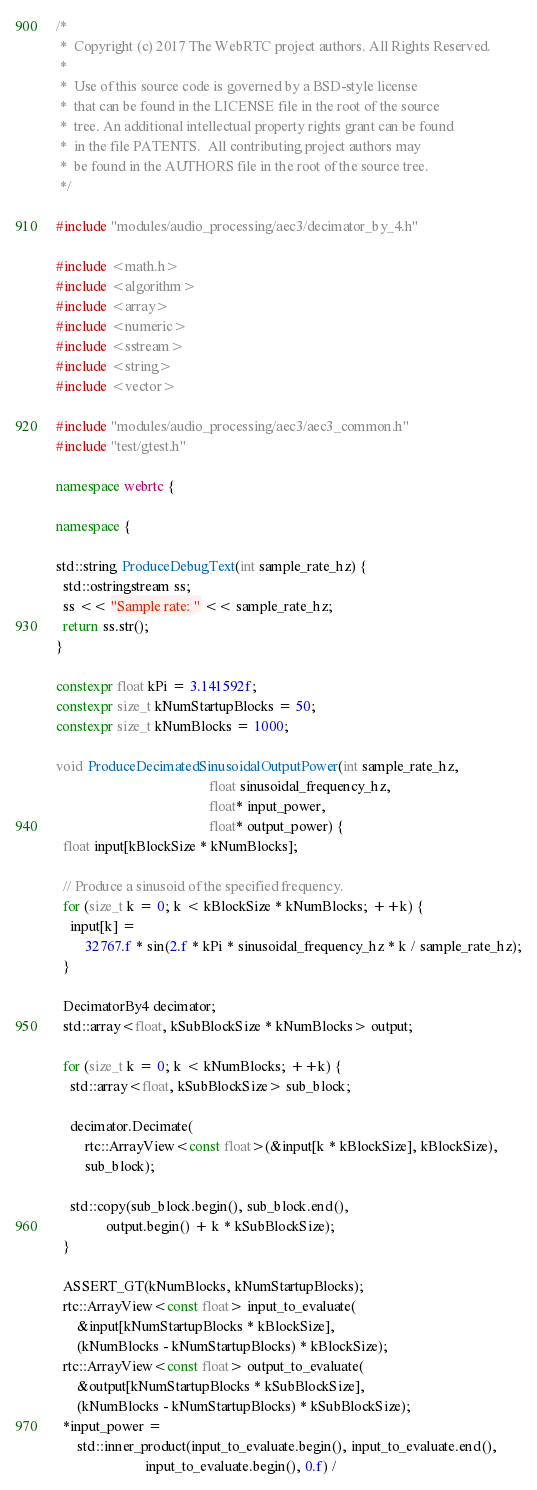Convert code to text. <code><loc_0><loc_0><loc_500><loc_500><_C++_>/*
 *  Copyright (c) 2017 The WebRTC project authors. All Rights Reserved.
 *
 *  Use of this source code is governed by a BSD-style license
 *  that can be found in the LICENSE file in the root of the source
 *  tree. An additional intellectual property rights grant can be found
 *  in the file PATENTS.  All contributing project authors may
 *  be found in the AUTHORS file in the root of the source tree.
 */

#include "modules/audio_processing/aec3/decimator_by_4.h"

#include <math.h>
#include <algorithm>
#include <array>
#include <numeric>
#include <sstream>
#include <string>
#include <vector>

#include "modules/audio_processing/aec3/aec3_common.h"
#include "test/gtest.h"

namespace webrtc {

namespace {

std::string ProduceDebugText(int sample_rate_hz) {
  std::ostringstream ss;
  ss << "Sample rate: " << sample_rate_hz;
  return ss.str();
}

constexpr float kPi = 3.141592f;
constexpr size_t kNumStartupBlocks = 50;
constexpr size_t kNumBlocks = 1000;

void ProduceDecimatedSinusoidalOutputPower(int sample_rate_hz,
                                           float sinusoidal_frequency_hz,
                                           float* input_power,
                                           float* output_power) {
  float input[kBlockSize * kNumBlocks];

  // Produce a sinusoid of the specified frequency.
  for (size_t k = 0; k < kBlockSize * kNumBlocks; ++k) {
    input[k] =
        32767.f * sin(2.f * kPi * sinusoidal_frequency_hz * k / sample_rate_hz);
  }

  DecimatorBy4 decimator;
  std::array<float, kSubBlockSize * kNumBlocks> output;

  for (size_t k = 0; k < kNumBlocks; ++k) {
    std::array<float, kSubBlockSize> sub_block;

    decimator.Decimate(
        rtc::ArrayView<const float>(&input[k * kBlockSize], kBlockSize),
        sub_block);

    std::copy(sub_block.begin(), sub_block.end(),
              output.begin() + k * kSubBlockSize);
  }

  ASSERT_GT(kNumBlocks, kNumStartupBlocks);
  rtc::ArrayView<const float> input_to_evaluate(
      &input[kNumStartupBlocks * kBlockSize],
      (kNumBlocks - kNumStartupBlocks) * kBlockSize);
  rtc::ArrayView<const float> output_to_evaluate(
      &output[kNumStartupBlocks * kSubBlockSize],
      (kNumBlocks - kNumStartupBlocks) * kSubBlockSize);
  *input_power =
      std::inner_product(input_to_evaluate.begin(), input_to_evaluate.end(),
                         input_to_evaluate.begin(), 0.f) /</code> 